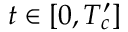<formula> <loc_0><loc_0><loc_500><loc_500>t \in [ 0 , T _ { c } ^ { \prime } ]</formula> 